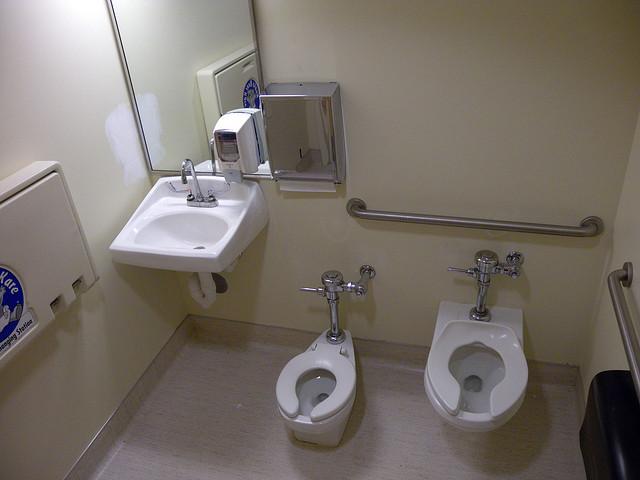Why is there a smaller toilet?
Answer briefly. Kids. Would it be awkward to use this restroom with another person?
Quick response, please. Yes. How many toilets are there?
Quick response, please. 2. 